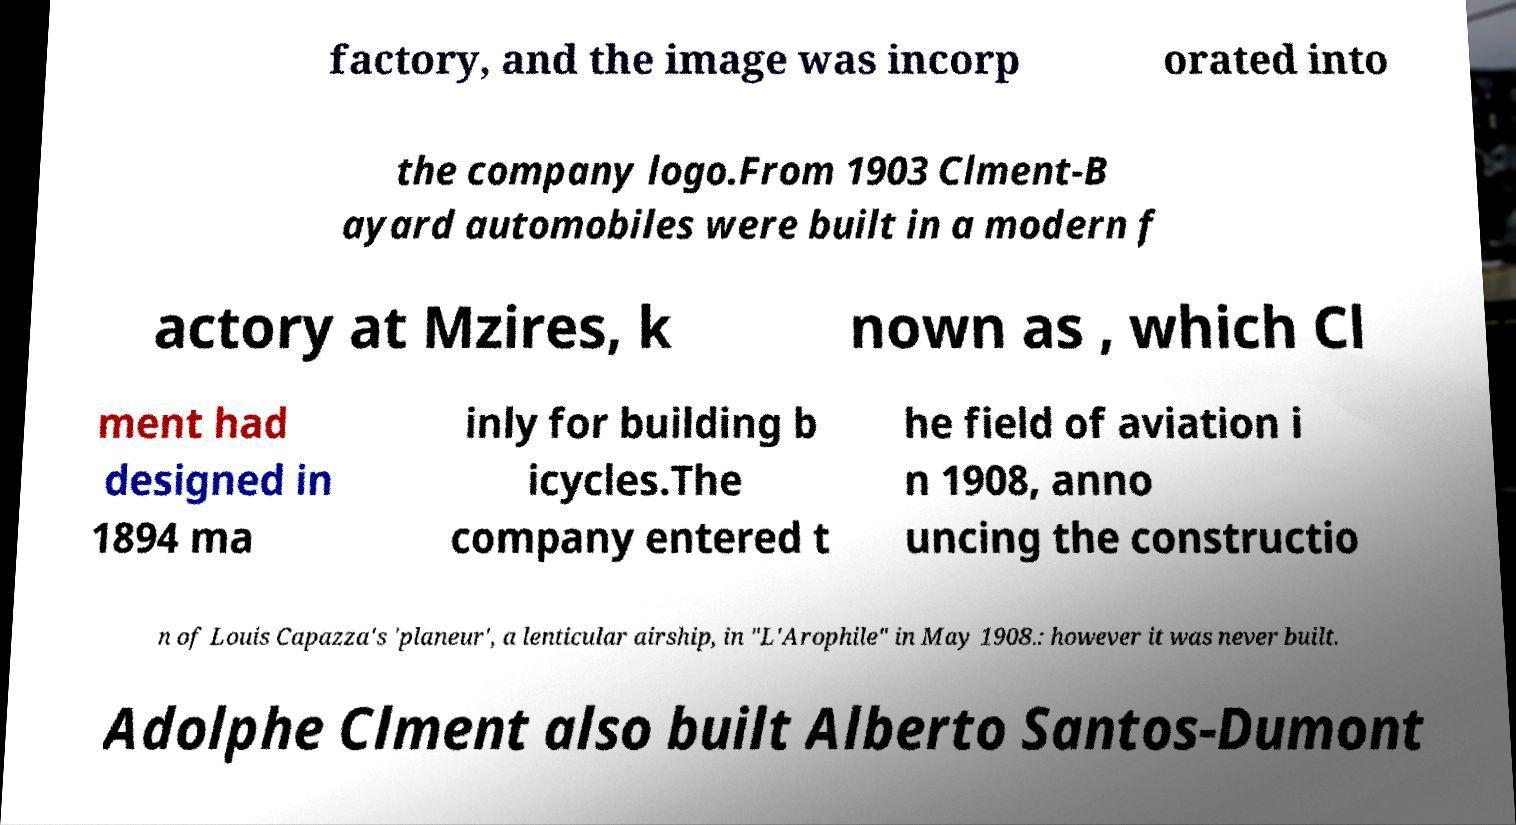Can you accurately transcribe the text from the provided image for me? factory, and the image was incorp orated into the company logo.From 1903 Clment-B ayard automobiles were built in a modern f actory at Mzires, k nown as , which Cl ment had designed in 1894 ma inly for building b icycles.The company entered t he field of aviation i n 1908, anno uncing the constructio n of Louis Capazza's 'planeur', a lenticular airship, in "L'Arophile" in May 1908.: however it was never built. Adolphe Clment also built Alberto Santos-Dumont 